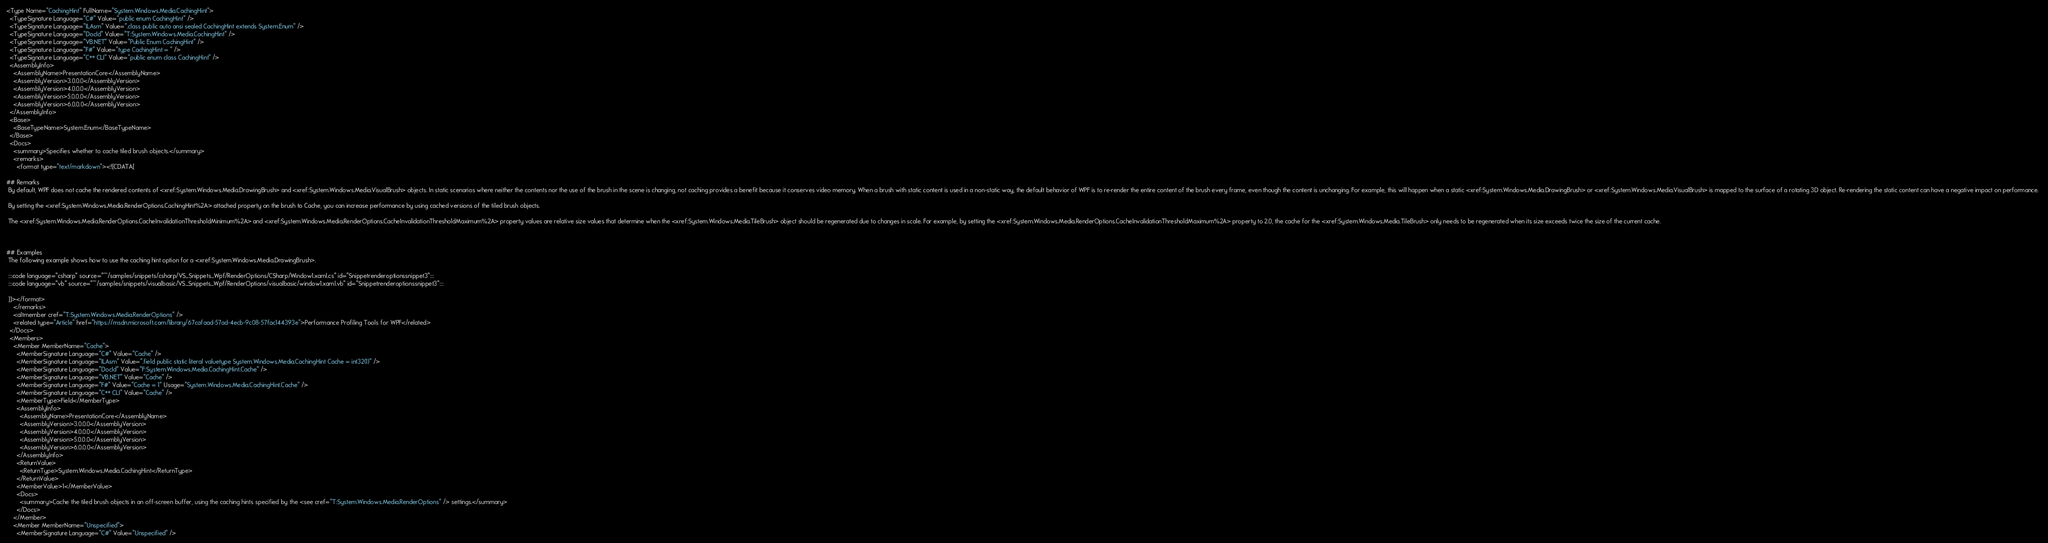Convert code to text. <code><loc_0><loc_0><loc_500><loc_500><_XML_><Type Name="CachingHint" FullName="System.Windows.Media.CachingHint">
  <TypeSignature Language="C#" Value="public enum CachingHint" />
  <TypeSignature Language="ILAsm" Value=".class public auto ansi sealed CachingHint extends System.Enum" />
  <TypeSignature Language="DocId" Value="T:System.Windows.Media.CachingHint" />
  <TypeSignature Language="VB.NET" Value="Public Enum CachingHint" />
  <TypeSignature Language="F#" Value="type CachingHint = " />
  <TypeSignature Language="C++ CLI" Value="public enum class CachingHint" />
  <AssemblyInfo>
    <AssemblyName>PresentationCore</AssemblyName>
    <AssemblyVersion>3.0.0.0</AssemblyVersion>
    <AssemblyVersion>4.0.0.0</AssemblyVersion>
    <AssemblyVersion>5.0.0.0</AssemblyVersion>
    <AssemblyVersion>6.0.0.0</AssemblyVersion>
  </AssemblyInfo>
  <Base>
    <BaseTypeName>System.Enum</BaseTypeName>
  </Base>
  <Docs>
    <summary>Specifies whether to cache tiled brush objects.</summary>
    <remarks>
      <format type="text/markdown"><![CDATA[  
  
## Remarks  
 By default, WPF does not cache the rendered contents of <xref:System.Windows.Media.DrawingBrush> and <xref:System.Windows.Media.VisualBrush> objects. In static scenarios where neither the contents nor the use of the brush in the scene is changing, not caching provides a benefit because it conserves video memory. When a brush with static content is used in a non-static way, the default behavior of WPF is to re-render the entire content of the brush every frame, even though the content is unchanging. For example, this will happen when a static <xref:System.Windows.Media.DrawingBrush> or <xref:System.Windows.Media.VisualBrush> is mapped to the surface of a rotating 3D object. Re-rendering the static content can have a negative impact on performance.  
  
 By setting the <xref:System.Windows.Media.RenderOptions.CachingHint%2A> attached property on the brush to Cache, you can increase performance by using cached versions of the tiled brush objects.  
  
 The <xref:System.Windows.Media.RenderOptions.CacheInvalidationThresholdMinimum%2A> and <xref:System.Windows.Media.RenderOptions.CacheInvalidationThresholdMaximum%2A> property values are relative size values that determine when the <xref:System.Windows.Media.TileBrush> object should be regenerated due to changes in scale. For example, by setting the <xref:System.Windows.Media.RenderOptions.CacheInvalidationThresholdMaximum%2A> property to 2.0, the cache for the <xref:System.Windows.Media.TileBrush> only needs to be regenerated when its size exceeds twice the size of the current cache.  
  
   
  
## Examples  
 The following example shows how to use the caching hint option for a <xref:System.Windows.Media.DrawingBrush>.  
  
 :::code language="csharp" source="~/samples/snippets/csharp/VS_Snippets_Wpf/RenderOptions/CSharp/Window1.xaml.cs" id="Snippetrenderoptionssnippet3":::
 :::code language="vb" source="~/samples/snippets/visualbasic/VS_Snippets_Wpf/RenderOptions/visualbasic/window1.xaml.vb" id="Snippetrenderoptionssnippet3":::  
  
 ]]></format>
    </remarks>
    <altmember cref="T:System.Windows.Media.RenderOptions" />
    <related type="Article" href="https://msdn.microsoft.com/library/67cafaad-57ad-4ecb-9c08-57fac144393e">Performance Profiling Tools for WPF</related>
  </Docs>
  <Members>
    <Member MemberName="Cache">
      <MemberSignature Language="C#" Value="Cache" />
      <MemberSignature Language="ILAsm" Value=".field public static literal valuetype System.Windows.Media.CachingHint Cache = int32(1)" />
      <MemberSignature Language="DocId" Value="F:System.Windows.Media.CachingHint.Cache" />
      <MemberSignature Language="VB.NET" Value="Cache" />
      <MemberSignature Language="F#" Value="Cache = 1" Usage="System.Windows.Media.CachingHint.Cache" />
      <MemberSignature Language="C++ CLI" Value="Cache" />
      <MemberType>Field</MemberType>
      <AssemblyInfo>
        <AssemblyName>PresentationCore</AssemblyName>
        <AssemblyVersion>3.0.0.0</AssemblyVersion>
        <AssemblyVersion>4.0.0.0</AssemblyVersion>
        <AssemblyVersion>5.0.0.0</AssemblyVersion>
        <AssemblyVersion>6.0.0.0</AssemblyVersion>
      </AssemblyInfo>
      <ReturnValue>
        <ReturnType>System.Windows.Media.CachingHint</ReturnType>
      </ReturnValue>
      <MemberValue>1</MemberValue>
      <Docs>
        <summary>Cache the tiled brush objects in an off-screen buffer, using the caching hints specified by the <see cref="T:System.Windows.Media.RenderOptions" /> settings.</summary>
      </Docs>
    </Member>
    <Member MemberName="Unspecified">
      <MemberSignature Language="C#" Value="Unspecified" /></code> 